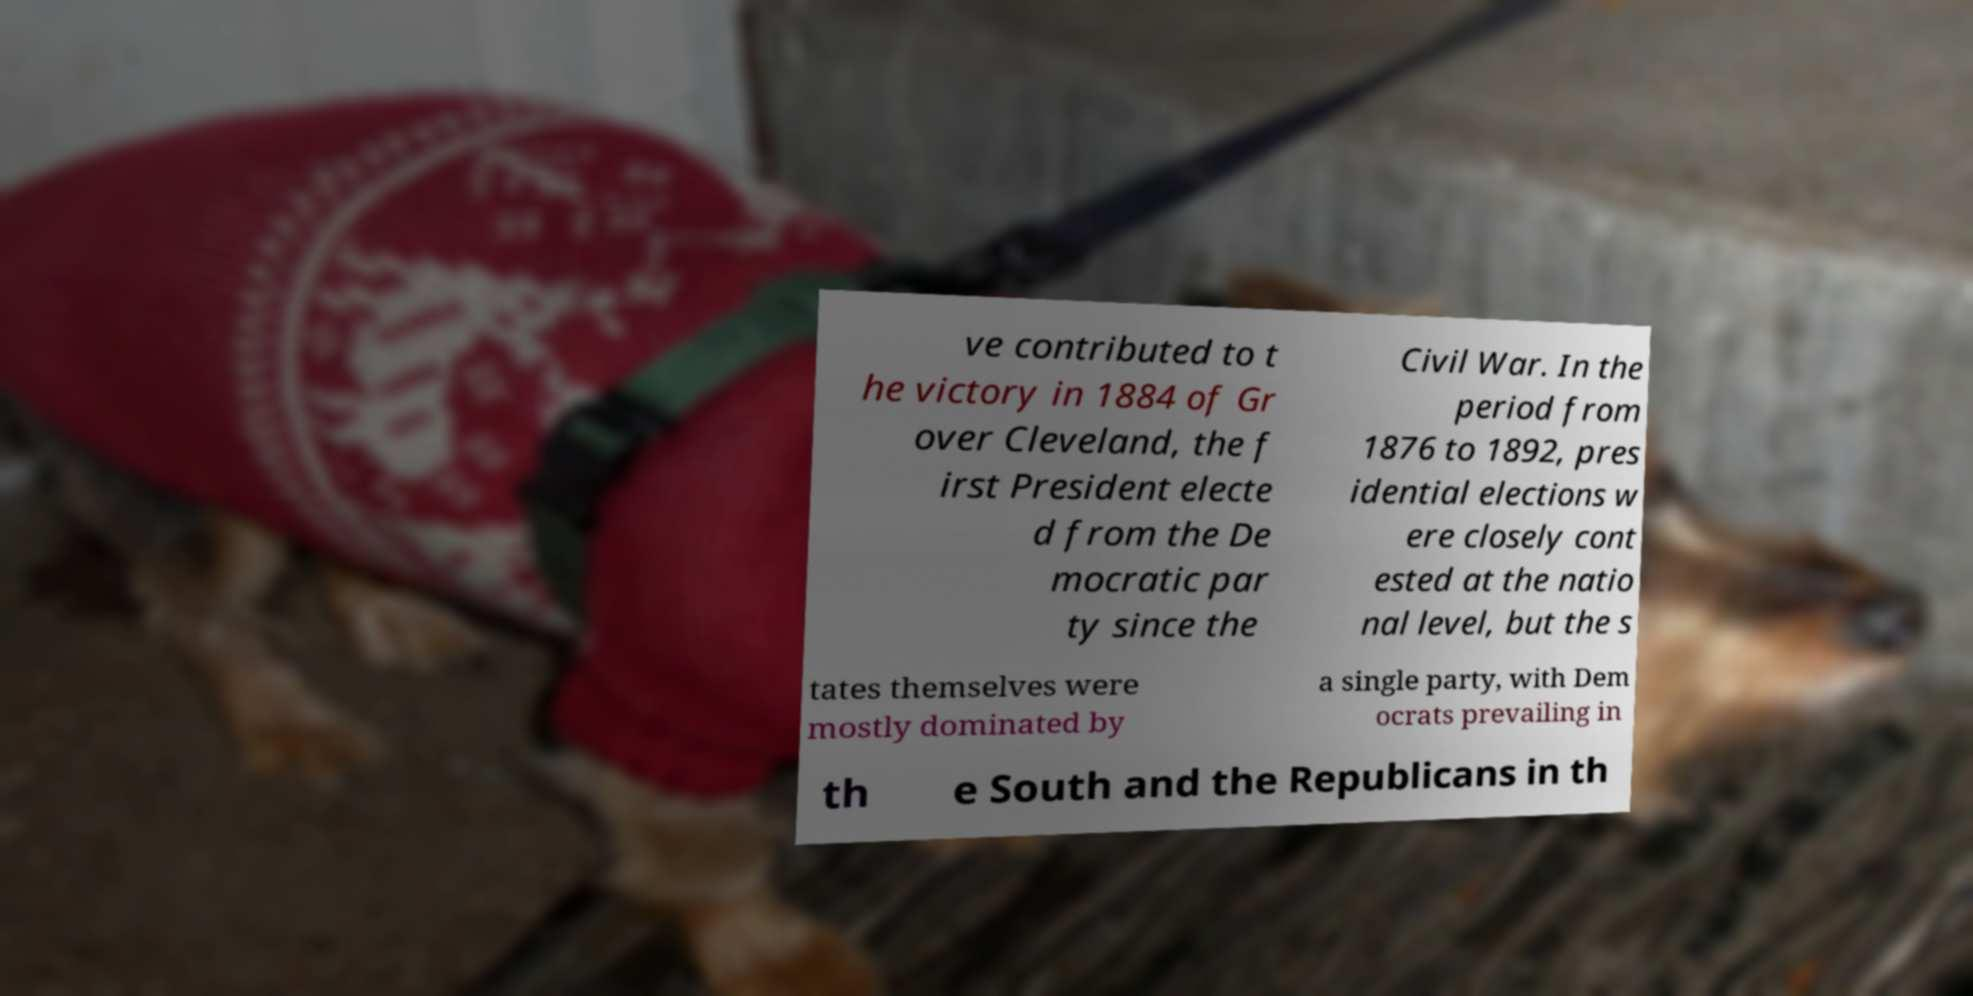What messages or text are displayed in this image? I need them in a readable, typed format. ve contributed to t he victory in 1884 of Gr over Cleveland, the f irst President electe d from the De mocratic par ty since the Civil War. In the period from 1876 to 1892, pres idential elections w ere closely cont ested at the natio nal level, but the s tates themselves were mostly dominated by a single party, with Dem ocrats prevailing in th e South and the Republicans in th 